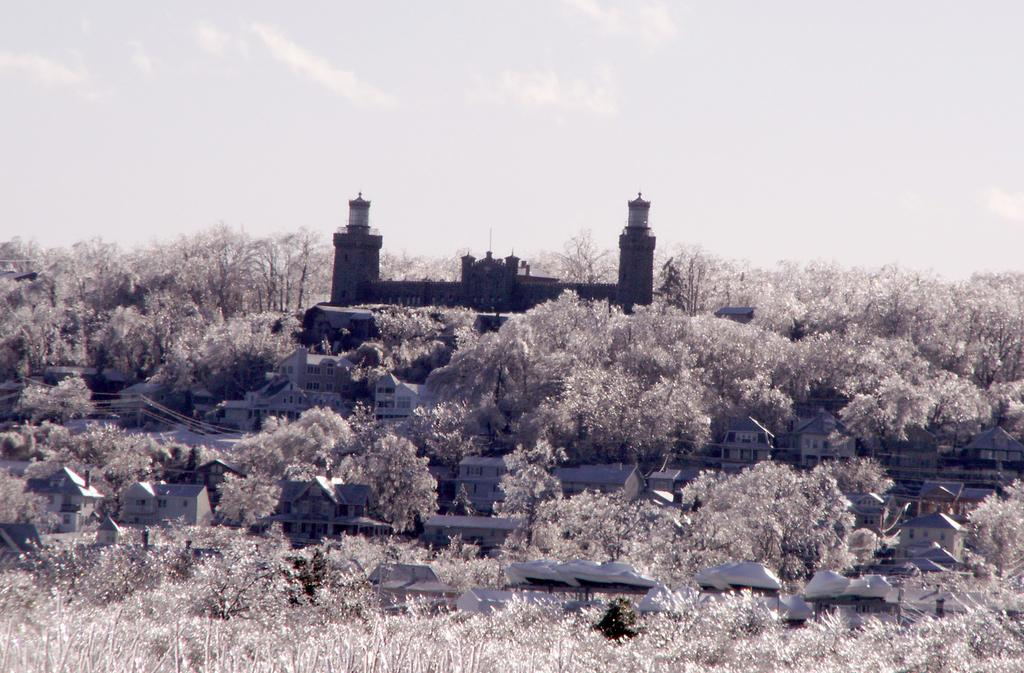What is the main subject in the middle of the picture? There is a building in the middle of the picture. What can be seen surrounding the building? There are trees around the building. What is visible in the background of the image? The sky is visible in the background of the image. Can you tell me how fast the clock is running in the image? There is no clock present in the image, so it is not possible to determine its speed. 